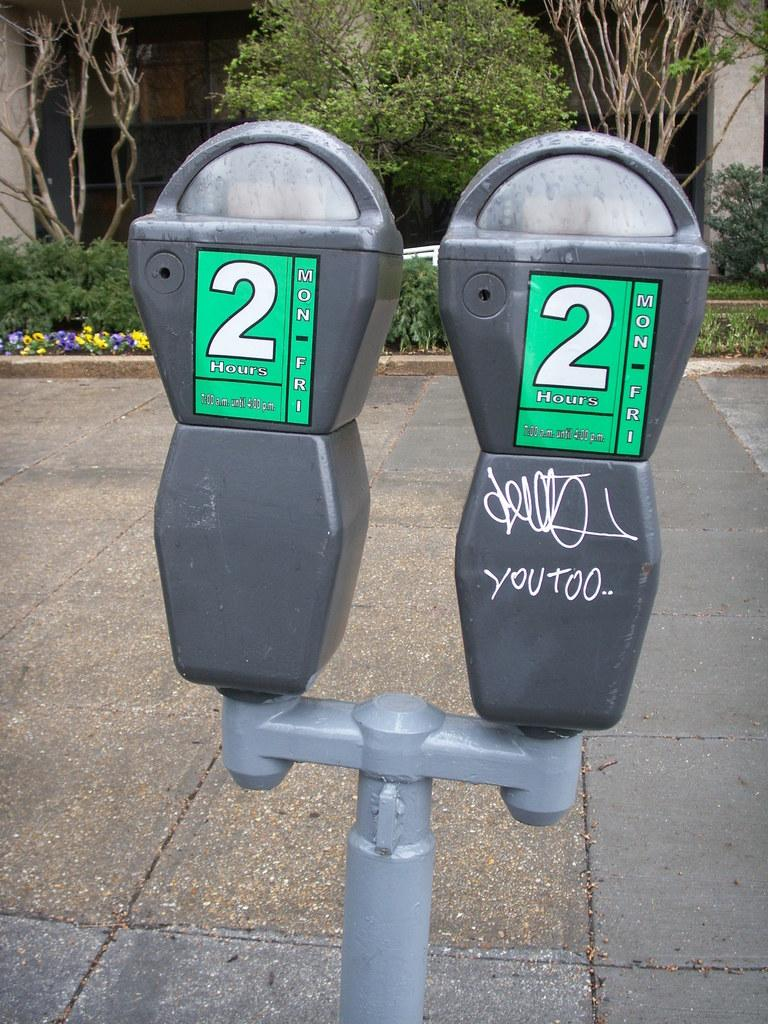<image>
Describe the image concisely. Parking meters have a 2 hour maximum before more change is needed. 